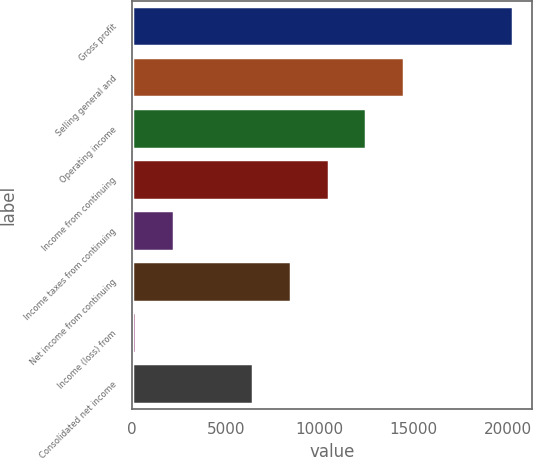<chart> <loc_0><loc_0><loc_500><loc_500><bar_chart><fcel>Gross profit<fcel>Selling general and<fcel>Operating income<fcel>Income from continuing<fcel>Income taxes from continuing<fcel>Net income from continuing<fcel>Income (loss) from<fcel>Consolidated net income<nl><fcel>20261<fcel>14468.2<fcel>12467.4<fcel>10466.6<fcel>2253.8<fcel>8465.8<fcel>253<fcel>6465<nl></chart> 